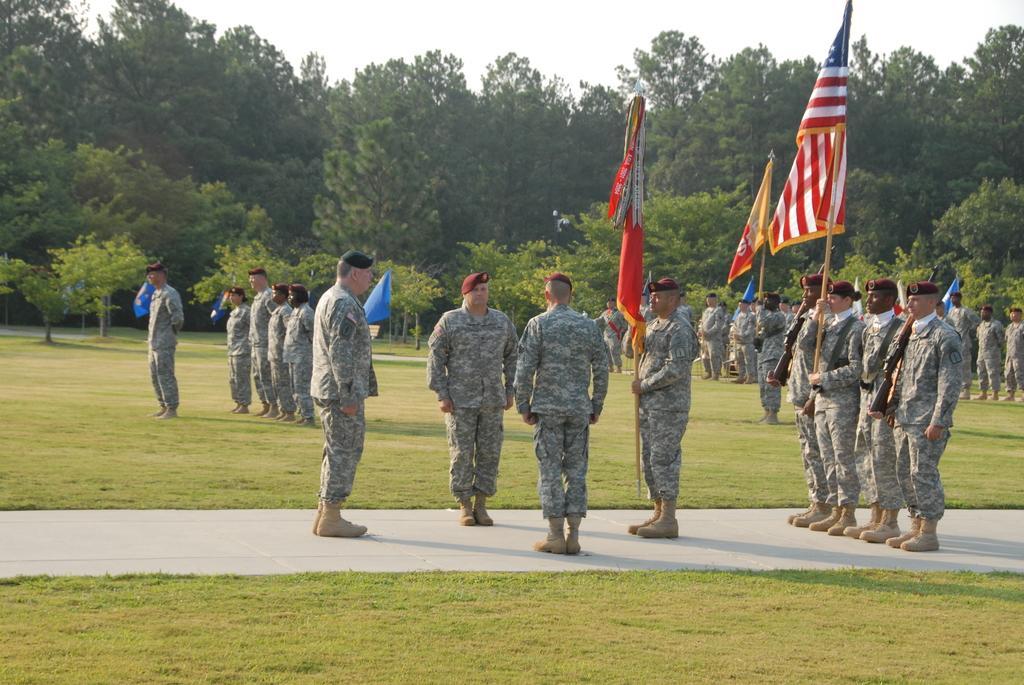Describe this image in one or two sentences. In this picture I can see few people standing on walk way and few people holding flags. I can see green grass. I can see trees in the background. I can see clear sky. 